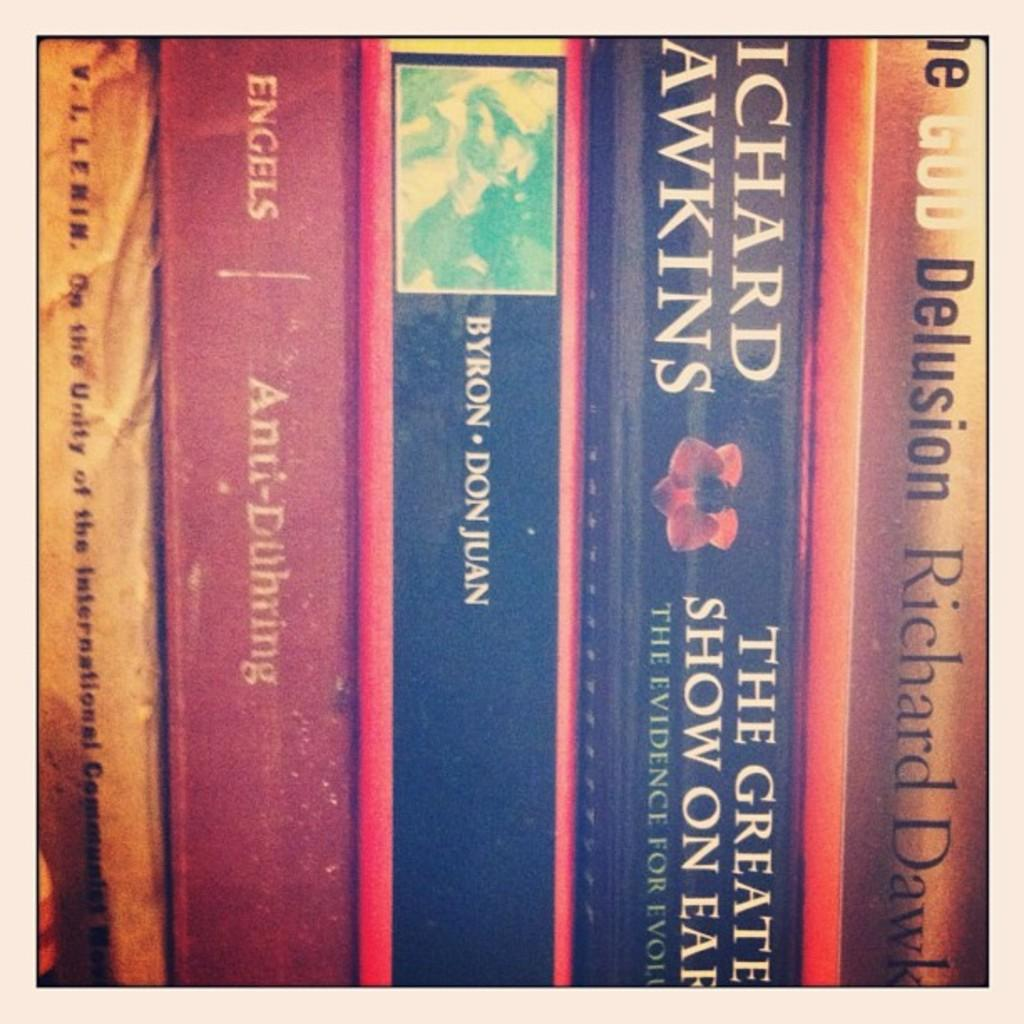<image>
Relay a brief, clear account of the picture shown. paperback books to include The Greatest Show On Earth 